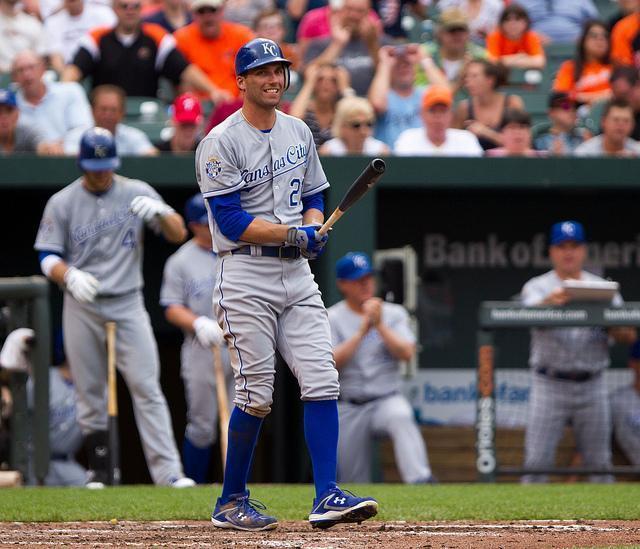How many people are there?
Give a very brief answer. 14. 